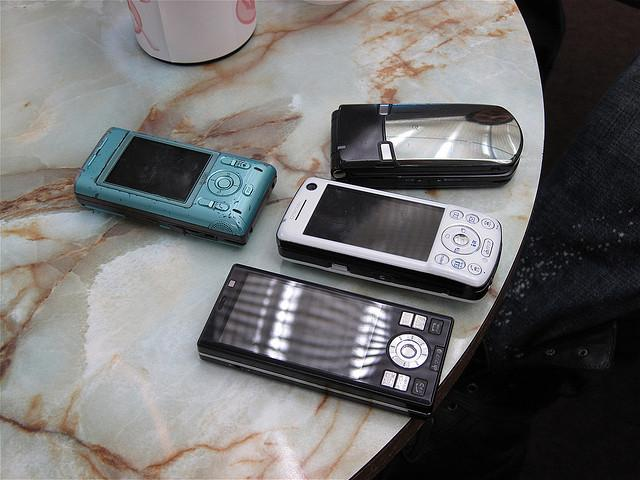What is decade are the phones most likely from? nineties 